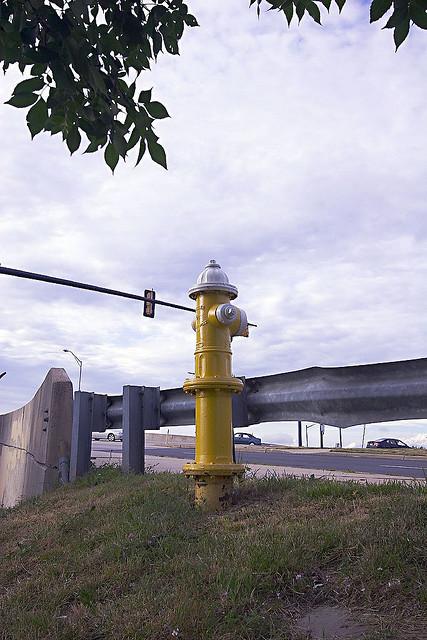Are there any cars driving by?
Be succinct. No. How tall is the fire hydrant?
Answer briefly. 4 ft. Has the safety railing ever been damaged?
Keep it brief. Yes. Is that a fire hydrant?
Short answer required. Yes. 